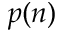<formula> <loc_0><loc_0><loc_500><loc_500>p ( n )</formula> 